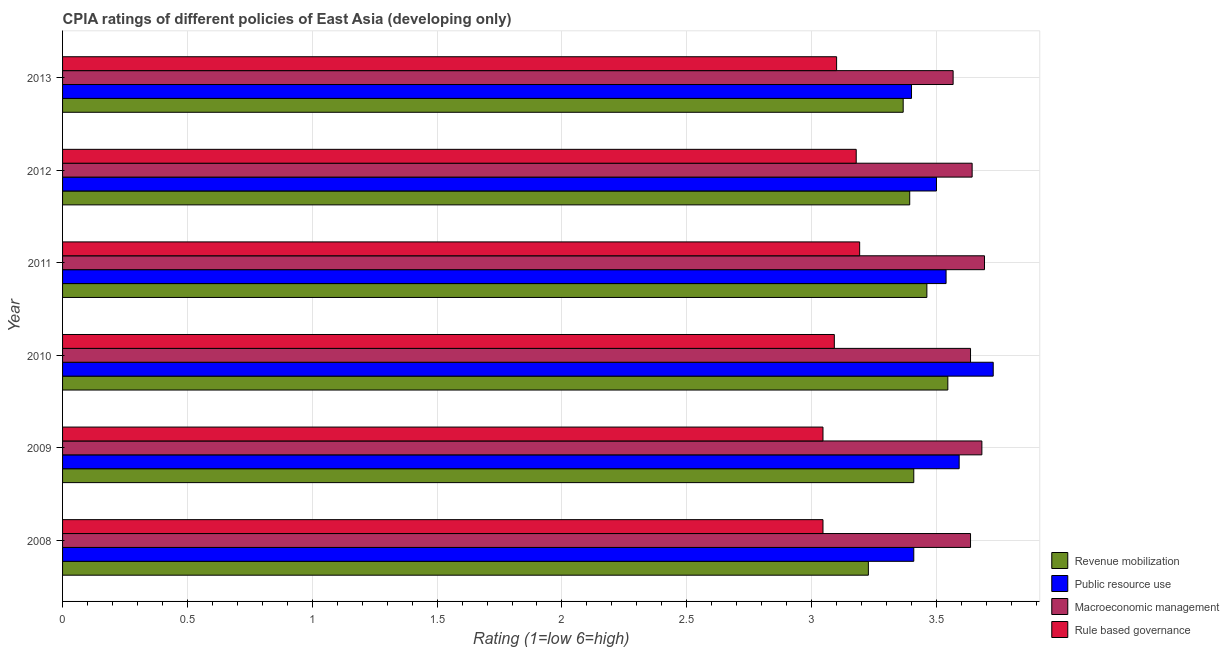How many different coloured bars are there?
Make the answer very short. 4. How many groups of bars are there?
Your answer should be compact. 6. Are the number of bars per tick equal to the number of legend labels?
Offer a terse response. Yes. Are the number of bars on each tick of the Y-axis equal?
Offer a terse response. Yes. How many bars are there on the 4th tick from the top?
Provide a succinct answer. 4. How many bars are there on the 4th tick from the bottom?
Your answer should be very brief. 4. What is the label of the 5th group of bars from the top?
Make the answer very short. 2009. In how many cases, is the number of bars for a given year not equal to the number of legend labels?
Your answer should be very brief. 0. What is the cpia rating of revenue mobilization in 2010?
Make the answer very short. 3.55. Across all years, what is the maximum cpia rating of revenue mobilization?
Your response must be concise. 3.55. Across all years, what is the minimum cpia rating of macroeconomic management?
Offer a terse response. 3.57. In which year was the cpia rating of revenue mobilization minimum?
Give a very brief answer. 2008. What is the total cpia rating of revenue mobilization in the graph?
Your response must be concise. 20.4. What is the difference between the cpia rating of revenue mobilization in 2008 and that in 2012?
Your answer should be very brief. -0.17. What is the difference between the cpia rating of public resource use in 2008 and the cpia rating of macroeconomic management in 2012?
Your response must be concise. -0.23. What is the average cpia rating of rule based governance per year?
Provide a short and direct response. 3.11. In how many years, is the cpia rating of macroeconomic management greater than 3.2 ?
Make the answer very short. 6. Is the difference between the cpia rating of macroeconomic management in 2008 and 2013 greater than the difference between the cpia rating of rule based governance in 2008 and 2013?
Your answer should be very brief. Yes. What is the difference between the highest and the second highest cpia rating of revenue mobilization?
Your answer should be very brief. 0.08. In how many years, is the cpia rating of rule based governance greater than the average cpia rating of rule based governance taken over all years?
Your answer should be very brief. 2. Is the sum of the cpia rating of rule based governance in 2010 and 2011 greater than the maximum cpia rating of revenue mobilization across all years?
Offer a terse response. Yes. Is it the case that in every year, the sum of the cpia rating of macroeconomic management and cpia rating of revenue mobilization is greater than the sum of cpia rating of rule based governance and cpia rating of public resource use?
Your answer should be very brief. Yes. What does the 4th bar from the top in 2008 represents?
Your answer should be very brief. Revenue mobilization. What does the 3rd bar from the bottom in 2010 represents?
Your response must be concise. Macroeconomic management. Is it the case that in every year, the sum of the cpia rating of revenue mobilization and cpia rating of public resource use is greater than the cpia rating of macroeconomic management?
Provide a short and direct response. Yes. How many bars are there?
Give a very brief answer. 24. Are all the bars in the graph horizontal?
Provide a short and direct response. Yes. How many years are there in the graph?
Your response must be concise. 6. Does the graph contain any zero values?
Make the answer very short. No. Does the graph contain grids?
Provide a short and direct response. Yes. Where does the legend appear in the graph?
Keep it short and to the point. Bottom right. How many legend labels are there?
Offer a very short reply. 4. What is the title of the graph?
Provide a succinct answer. CPIA ratings of different policies of East Asia (developing only). Does "Tertiary education" appear as one of the legend labels in the graph?
Make the answer very short. No. What is the label or title of the X-axis?
Ensure brevity in your answer.  Rating (1=low 6=high). What is the label or title of the Y-axis?
Keep it short and to the point. Year. What is the Rating (1=low 6=high) of Revenue mobilization in 2008?
Your response must be concise. 3.23. What is the Rating (1=low 6=high) of Public resource use in 2008?
Your answer should be very brief. 3.41. What is the Rating (1=low 6=high) of Macroeconomic management in 2008?
Your response must be concise. 3.64. What is the Rating (1=low 6=high) in Rule based governance in 2008?
Your response must be concise. 3.05. What is the Rating (1=low 6=high) in Revenue mobilization in 2009?
Give a very brief answer. 3.41. What is the Rating (1=low 6=high) in Public resource use in 2009?
Your answer should be very brief. 3.59. What is the Rating (1=low 6=high) in Macroeconomic management in 2009?
Your answer should be very brief. 3.68. What is the Rating (1=low 6=high) of Rule based governance in 2009?
Provide a succinct answer. 3.05. What is the Rating (1=low 6=high) of Revenue mobilization in 2010?
Your answer should be compact. 3.55. What is the Rating (1=low 6=high) of Public resource use in 2010?
Your response must be concise. 3.73. What is the Rating (1=low 6=high) of Macroeconomic management in 2010?
Make the answer very short. 3.64. What is the Rating (1=low 6=high) in Rule based governance in 2010?
Your answer should be very brief. 3.09. What is the Rating (1=low 6=high) in Revenue mobilization in 2011?
Give a very brief answer. 3.46. What is the Rating (1=low 6=high) of Public resource use in 2011?
Make the answer very short. 3.54. What is the Rating (1=low 6=high) in Macroeconomic management in 2011?
Your answer should be very brief. 3.69. What is the Rating (1=low 6=high) in Rule based governance in 2011?
Your answer should be compact. 3.19. What is the Rating (1=low 6=high) of Revenue mobilization in 2012?
Ensure brevity in your answer.  3.39. What is the Rating (1=low 6=high) of Macroeconomic management in 2012?
Ensure brevity in your answer.  3.64. What is the Rating (1=low 6=high) in Rule based governance in 2012?
Your answer should be very brief. 3.18. What is the Rating (1=low 6=high) of Revenue mobilization in 2013?
Offer a terse response. 3.37. What is the Rating (1=low 6=high) of Public resource use in 2013?
Give a very brief answer. 3.4. What is the Rating (1=low 6=high) of Macroeconomic management in 2013?
Offer a terse response. 3.57. Across all years, what is the maximum Rating (1=low 6=high) in Revenue mobilization?
Your answer should be compact. 3.55. Across all years, what is the maximum Rating (1=low 6=high) of Public resource use?
Give a very brief answer. 3.73. Across all years, what is the maximum Rating (1=low 6=high) in Macroeconomic management?
Your answer should be very brief. 3.69. Across all years, what is the maximum Rating (1=low 6=high) in Rule based governance?
Provide a short and direct response. 3.19. Across all years, what is the minimum Rating (1=low 6=high) of Revenue mobilization?
Your answer should be compact. 3.23. Across all years, what is the minimum Rating (1=low 6=high) in Macroeconomic management?
Make the answer very short. 3.57. Across all years, what is the minimum Rating (1=low 6=high) of Rule based governance?
Ensure brevity in your answer.  3.05. What is the total Rating (1=low 6=high) of Revenue mobilization in the graph?
Provide a short and direct response. 20.4. What is the total Rating (1=low 6=high) in Public resource use in the graph?
Make the answer very short. 21.17. What is the total Rating (1=low 6=high) in Macroeconomic management in the graph?
Give a very brief answer. 21.86. What is the total Rating (1=low 6=high) of Rule based governance in the graph?
Provide a short and direct response. 18.65. What is the difference between the Rating (1=low 6=high) in Revenue mobilization in 2008 and that in 2009?
Offer a very short reply. -0.18. What is the difference between the Rating (1=low 6=high) of Public resource use in 2008 and that in 2009?
Ensure brevity in your answer.  -0.18. What is the difference between the Rating (1=low 6=high) in Macroeconomic management in 2008 and that in 2009?
Provide a succinct answer. -0.05. What is the difference between the Rating (1=low 6=high) in Rule based governance in 2008 and that in 2009?
Your answer should be very brief. 0. What is the difference between the Rating (1=low 6=high) of Revenue mobilization in 2008 and that in 2010?
Keep it short and to the point. -0.32. What is the difference between the Rating (1=low 6=high) of Public resource use in 2008 and that in 2010?
Your answer should be very brief. -0.32. What is the difference between the Rating (1=low 6=high) in Macroeconomic management in 2008 and that in 2010?
Your answer should be compact. 0. What is the difference between the Rating (1=low 6=high) in Rule based governance in 2008 and that in 2010?
Your answer should be very brief. -0.05. What is the difference between the Rating (1=low 6=high) of Revenue mobilization in 2008 and that in 2011?
Provide a succinct answer. -0.23. What is the difference between the Rating (1=low 6=high) of Public resource use in 2008 and that in 2011?
Ensure brevity in your answer.  -0.13. What is the difference between the Rating (1=low 6=high) of Macroeconomic management in 2008 and that in 2011?
Your answer should be compact. -0.06. What is the difference between the Rating (1=low 6=high) of Rule based governance in 2008 and that in 2011?
Keep it short and to the point. -0.15. What is the difference between the Rating (1=low 6=high) of Revenue mobilization in 2008 and that in 2012?
Your answer should be very brief. -0.17. What is the difference between the Rating (1=low 6=high) in Public resource use in 2008 and that in 2012?
Offer a very short reply. -0.09. What is the difference between the Rating (1=low 6=high) of Macroeconomic management in 2008 and that in 2012?
Offer a very short reply. -0.01. What is the difference between the Rating (1=low 6=high) in Rule based governance in 2008 and that in 2012?
Ensure brevity in your answer.  -0.13. What is the difference between the Rating (1=low 6=high) of Revenue mobilization in 2008 and that in 2013?
Offer a very short reply. -0.14. What is the difference between the Rating (1=low 6=high) of Public resource use in 2008 and that in 2013?
Provide a short and direct response. 0.01. What is the difference between the Rating (1=low 6=high) of Macroeconomic management in 2008 and that in 2013?
Provide a short and direct response. 0.07. What is the difference between the Rating (1=low 6=high) in Rule based governance in 2008 and that in 2013?
Your response must be concise. -0.05. What is the difference between the Rating (1=low 6=high) of Revenue mobilization in 2009 and that in 2010?
Provide a succinct answer. -0.14. What is the difference between the Rating (1=low 6=high) of Public resource use in 2009 and that in 2010?
Offer a very short reply. -0.14. What is the difference between the Rating (1=low 6=high) in Macroeconomic management in 2009 and that in 2010?
Ensure brevity in your answer.  0.05. What is the difference between the Rating (1=low 6=high) of Rule based governance in 2009 and that in 2010?
Ensure brevity in your answer.  -0.05. What is the difference between the Rating (1=low 6=high) of Revenue mobilization in 2009 and that in 2011?
Offer a terse response. -0.05. What is the difference between the Rating (1=low 6=high) of Public resource use in 2009 and that in 2011?
Give a very brief answer. 0.05. What is the difference between the Rating (1=low 6=high) in Macroeconomic management in 2009 and that in 2011?
Your answer should be very brief. -0.01. What is the difference between the Rating (1=low 6=high) of Rule based governance in 2009 and that in 2011?
Offer a very short reply. -0.15. What is the difference between the Rating (1=low 6=high) in Revenue mobilization in 2009 and that in 2012?
Ensure brevity in your answer.  0.02. What is the difference between the Rating (1=low 6=high) in Public resource use in 2009 and that in 2012?
Offer a very short reply. 0.09. What is the difference between the Rating (1=low 6=high) of Macroeconomic management in 2009 and that in 2012?
Provide a short and direct response. 0.04. What is the difference between the Rating (1=low 6=high) in Rule based governance in 2009 and that in 2012?
Offer a terse response. -0.13. What is the difference between the Rating (1=low 6=high) of Revenue mobilization in 2009 and that in 2013?
Your answer should be compact. 0.04. What is the difference between the Rating (1=low 6=high) in Public resource use in 2009 and that in 2013?
Your response must be concise. 0.19. What is the difference between the Rating (1=low 6=high) in Macroeconomic management in 2009 and that in 2013?
Give a very brief answer. 0.12. What is the difference between the Rating (1=low 6=high) in Rule based governance in 2009 and that in 2013?
Give a very brief answer. -0.05. What is the difference between the Rating (1=low 6=high) of Revenue mobilization in 2010 and that in 2011?
Offer a very short reply. 0.08. What is the difference between the Rating (1=low 6=high) in Public resource use in 2010 and that in 2011?
Ensure brevity in your answer.  0.19. What is the difference between the Rating (1=low 6=high) of Macroeconomic management in 2010 and that in 2011?
Your answer should be compact. -0.06. What is the difference between the Rating (1=low 6=high) in Rule based governance in 2010 and that in 2011?
Offer a very short reply. -0.1. What is the difference between the Rating (1=low 6=high) in Revenue mobilization in 2010 and that in 2012?
Provide a succinct answer. 0.15. What is the difference between the Rating (1=low 6=high) of Public resource use in 2010 and that in 2012?
Offer a very short reply. 0.23. What is the difference between the Rating (1=low 6=high) in Macroeconomic management in 2010 and that in 2012?
Give a very brief answer. -0.01. What is the difference between the Rating (1=low 6=high) in Rule based governance in 2010 and that in 2012?
Offer a terse response. -0.09. What is the difference between the Rating (1=low 6=high) of Revenue mobilization in 2010 and that in 2013?
Offer a terse response. 0.18. What is the difference between the Rating (1=low 6=high) in Public resource use in 2010 and that in 2013?
Offer a terse response. 0.33. What is the difference between the Rating (1=low 6=high) in Macroeconomic management in 2010 and that in 2013?
Keep it short and to the point. 0.07. What is the difference between the Rating (1=low 6=high) in Rule based governance in 2010 and that in 2013?
Keep it short and to the point. -0.01. What is the difference between the Rating (1=low 6=high) of Revenue mobilization in 2011 and that in 2012?
Keep it short and to the point. 0.07. What is the difference between the Rating (1=low 6=high) of Public resource use in 2011 and that in 2012?
Make the answer very short. 0.04. What is the difference between the Rating (1=low 6=high) in Macroeconomic management in 2011 and that in 2012?
Make the answer very short. 0.05. What is the difference between the Rating (1=low 6=high) of Rule based governance in 2011 and that in 2012?
Your response must be concise. 0.01. What is the difference between the Rating (1=low 6=high) of Revenue mobilization in 2011 and that in 2013?
Keep it short and to the point. 0.09. What is the difference between the Rating (1=low 6=high) in Public resource use in 2011 and that in 2013?
Make the answer very short. 0.14. What is the difference between the Rating (1=low 6=high) in Macroeconomic management in 2011 and that in 2013?
Your answer should be very brief. 0.13. What is the difference between the Rating (1=low 6=high) in Rule based governance in 2011 and that in 2013?
Your response must be concise. 0.09. What is the difference between the Rating (1=low 6=high) in Revenue mobilization in 2012 and that in 2013?
Make the answer very short. 0.03. What is the difference between the Rating (1=low 6=high) of Public resource use in 2012 and that in 2013?
Your answer should be compact. 0.1. What is the difference between the Rating (1=low 6=high) in Macroeconomic management in 2012 and that in 2013?
Ensure brevity in your answer.  0.08. What is the difference between the Rating (1=low 6=high) in Rule based governance in 2012 and that in 2013?
Offer a terse response. 0.08. What is the difference between the Rating (1=low 6=high) of Revenue mobilization in 2008 and the Rating (1=low 6=high) of Public resource use in 2009?
Provide a succinct answer. -0.36. What is the difference between the Rating (1=low 6=high) in Revenue mobilization in 2008 and the Rating (1=low 6=high) in Macroeconomic management in 2009?
Make the answer very short. -0.45. What is the difference between the Rating (1=low 6=high) of Revenue mobilization in 2008 and the Rating (1=low 6=high) of Rule based governance in 2009?
Provide a short and direct response. 0.18. What is the difference between the Rating (1=low 6=high) of Public resource use in 2008 and the Rating (1=low 6=high) of Macroeconomic management in 2009?
Your answer should be very brief. -0.27. What is the difference between the Rating (1=low 6=high) of Public resource use in 2008 and the Rating (1=low 6=high) of Rule based governance in 2009?
Your response must be concise. 0.36. What is the difference between the Rating (1=low 6=high) in Macroeconomic management in 2008 and the Rating (1=low 6=high) in Rule based governance in 2009?
Give a very brief answer. 0.59. What is the difference between the Rating (1=low 6=high) in Revenue mobilization in 2008 and the Rating (1=low 6=high) in Macroeconomic management in 2010?
Provide a short and direct response. -0.41. What is the difference between the Rating (1=low 6=high) of Revenue mobilization in 2008 and the Rating (1=low 6=high) of Rule based governance in 2010?
Your answer should be very brief. 0.14. What is the difference between the Rating (1=low 6=high) in Public resource use in 2008 and the Rating (1=low 6=high) in Macroeconomic management in 2010?
Offer a terse response. -0.23. What is the difference between the Rating (1=low 6=high) of Public resource use in 2008 and the Rating (1=low 6=high) of Rule based governance in 2010?
Offer a terse response. 0.32. What is the difference between the Rating (1=low 6=high) in Macroeconomic management in 2008 and the Rating (1=low 6=high) in Rule based governance in 2010?
Ensure brevity in your answer.  0.55. What is the difference between the Rating (1=low 6=high) of Revenue mobilization in 2008 and the Rating (1=low 6=high) of Public resource use in 2011?
Provide a short and direct response. -0.31. What is the difference between the Rating (1=low 6=high) in Revenue mobilization in 2008 and the Rating (1=low 6=high) in Macroeconomic management in 2011?
Ensure brevity in your answer.  -0.47. What is the difference between the Rating (1=low 6=high) in Revenue mobilization in 2008 and the Rating (1=low 6=high) in Rule based governance in 2011?
Keep it short and to the point. 0.04. What is the difference between the Rating (1=low 6=high) in Public resource use in 2008 and the Rating (1=low 6=high) in Macroeconomic management in 2011?
Your response must be concise. -0.28. What is the difference between the Rating (1=low 6=high) of Public resource use in 2008 and the Rating (1=low 6=high) of Rule based governance in 2011?
Ensure brevity in your answer.  0.22. What is the difference between the Rating (1=low 6=high) in Macroeconomic management in 2008 and the Rating (1=low 6=high) in Rule based governance in 2011?
Make the answer very short. 0.44. What is the difference between the Rating (1=low 6=high) of Revenue mobilization in 2008 and the Rating (1=low 6=high) of Public resource use in 2012?
Ensure brevity in your answer.  -0.27. What is the difference between the Rating (1=low 6=high) of Revenue mobilization in 2008 and the Rating (1=low 6=high) of Macroeconomic management in 2012?
Keep it short and to the point. -0.42. What is the difference between the Rating (1=low 6=high) in Revenue mobilization in 2008 and the Rating (1=low 6=high) in Rule based governance in 2012?
Keep it short and to the point. 0.05. What is the difference between the Rating (1=low 6=high) of Public resource use in 2008 and the Rating (1=low 6=high) of Macroeconomic management in 2012?
Make the answer very short. -0.23. What is the difference between the Rating (1=low 6=high) of Public resource use in 2008 and the Rating (1=low 6=high) of Rule based governance in 2012?
Make the answer very short. 0.23. What is the difference between the Rating (1=low 6=high) of Macroeconomic management in 2008 and the Rating (1=low 6=high) of Rule based governance in 2012?
Give a very brief answer. 0.46. What is the difference between the Rating (1=low 6=high) of Revenue mobilization in 2008 and the Rating (1=low 6=high) of Public resource use in 2013?
Keep it short and to the point. -0.17. What is the difference between the Rating (1=low 6=high) of Revenue mobilization in 2008 and the Rating (1=low 6=high) of Macroeconomic management in 2013?
Provide a short and direct response. -0.34. What is the difference between the Rating (1=low 6=high) of Revenue mobilization in 2008 and the Rating (1=low 6=high) of Rule based governance in 2013?
Provide a short and direct response. 0.13. What is the difference between the Rating (1=low 6=high) of Public resource use in 2008 and the Rating (1=low 6=high) of Macroeconomic management in 2013?
Keep it short and to the point. -0.16. What is the difference between the Rating (1=low 6=high) in Public resource use in 2008 and the Rating (1=low 6=high) in Rule based governance in 2013?
Keep it short and to the point. 0.31. What is the difference between the Rating (1=low 6=high) of Macroeconomic management in 2008 and the Rating (1=low 6=high) of Rule based governance in 2013?
Provide a succinct answer. 0.54. What is the difference between the Rating (1=low 6=high) of Revenue mobilization in 2009 and the Rating (1=low 6=high) of Public resource use in 2010?
Your answer should be compact. -0.32. What is the difference between the Rating (1=low 6=high) in Revenue mobilization in 2009 and the Rating (1=low 6=high) in Macroeconomic management in 2010?
Offer a terse response. -0.23. What is the difference between the Rating (1=low 6=high) in Revenue mobilization in 2009 and the Rating (1=low 6=high) in Rule based governance in 2010?
Ensure brevity in your answer.  0.32. What is the difference between the Rating (1=low 6=high) of Public resource use in 2009 and the Rating (1=low 6=high) of Macroeconomic management in 2010?
Keep it short and to the point. -0.05. What is the difference between the Rating (1=low 6=high) of Macroeconomic management in 2009 and the Rating (1=low 6=high) of Rule based governance in 2010?
Provide a short and direct response. 0.59. What is the difference between the Rating (1=low 6=high) of Revenue mobilization in 2009 and the Rating (1=low 6=high) of Public resource use in 2011?
Provide a short and direct response. -0.13. What is the difference between the Rating (1=low 6=high) of Revenue mobilization in 2009 and the Rating (1=low 6=high) of Macroeconomic management in 2011?
Keep it short and to the point. -0.28. What is the difference between the Rating (1=low 6=high) in Revenue mobilization in 2009 and the Rating (1=low 6=high) in Rule based governance in 2011?
Your answer should be very brief. 0.22. What is the difference between the Rating (1=low 6=high) of Public resource use in 2009 and the Rating (1=low 6=high) of Macroeconomic management in 2011?
Offer a terse response. -0.1. What is the difference between the Rating (1=low 6=high) of Public resource use in 2009 and the Rating (1=low 6=high) of Rule based governance in 2011?
Your response must be concise. 0.4. What is the difference between the Rating (1=low 6=high) of Macroeconomic management in 2009 and the Rating (1=low 6=high) of Rule based governance in 2011?
Provide a succinct answer. 0.49. What is the difference between the Rating (1=low 6=high) in Revenue mobilization in 2009 and the Rating (1=low 6=high) in Public resource use in 2012?
Make the answer very short. -0.09. What is the difference between the Rating (1=low 6=high) of Revenue mobilization in 2009 and the Rating (1=low 6=high) of Macroeconomic management in 2012?
Make the answer very short. -0.23. What is the difference between the Rating (1=low 6=high) of Revenue mobilization in 2009 and the Rating (1=low 6=high) of Rule based governance in 2012?
Make the answer very short. 0.23. What is the difference between the Rating (1=low 6=high) in Public resource use in 2009 and the Rating (1=low 6=high) in Macroeconomic management in 2012?
Provide a short and direct response. -0.05. What is the difference between the Rating (1=low 6=high) in Public resource use in 2009 and the Rating (1=low 6=high) in Rule based governance in 2012?
Provide a short and direct response. 0.41. What is the difference between the Rating (1=low 6=high) in Macroeconomic management in 2009 and the Rating (1=low 6=high) in Rule based governance in 2012?
Ensure brevity in your answer.  0.5. What is the difference between the Rating (1=low 6=high) in Revenue mobilization in 2009 and the Rating (1=low 6=high) in Public resource use in 2013?
Ensure brevity in your answer.  0.01. What is the difference between the Rating (1=low 6=high) in Revenue mobilization in 2009 and the Rating (1=low 6=high) in Macroeconomic management in 2013?
Your answer should be very brief. -0.16. What is the difference between the Rating (1=low 6=high) in Revenue mobilization in 2009 and the Rating (1=low 6=high) in Rule based governance in 2013?
Ensure brevity in your answer.  0.31. What is the difference between the Rating (1=low 6=high) of Public resource use in 2009 and the Rating (1=low 6=high) of Macroeconomic management in 2013?
Offer a very short reply. 0.02. What is the difference between the Rating (1=low 6=high) of Public resource use in 2009 and the Rating (1=low 6=high) of Rule based governance in 2013?
Offer a very short reply. 0.49. What is the difference between the Rating (1=low 6=high) of Macroeconomic management in 2009 and the Rating (1=low 6=high) of Rule based governance in 2013?
Offer a very short reply. 0.58. What is the difference between the Rating (1=low 6=high) of Revenue mobilization in 2010 and the Rating (1=low 6=high) of Public resource use in 2011?
Ensure brevity in your answer.  0.01. What is the difference between the Rating (1=low 6=high) of Revenue mobilization in 2010 and the Rating (1=low 6=high) of Macroeconomic management in 2011?
Ensure brevity in your answer.  -0.15. What is the difference between the Rating (1=low 6=high) of Revenue mobilization in 2010 and the Rating (1=low 6=high) of Rule based governance in 2011?
Make the answer very short. 0.35. What is the difference between the Rating (1=low 6=high) in Public resource use in 2010 and the Rating (1=low 6=high) in Macroeconomic management in 2011?
Your response must be concise. 0.04. What is the difference between the Rating (1=low 6=high) in Public resource use in 2010 and the Rating (1=low 6=high) in Rule based governance in 2011?
Your response must be concise. 0.54. What is the difference between the Rating (1=low 6=high) of Macroeconomic management in 2010 and the Rating (1=low 6=high) of Rule based governance in 2011?
Keep it short and to the point. 0.44. What is the difference between the Rating (1=low 6=high) in Revenue mobilization in 2010 and the Rating (1=low 6=high) in Public resource use in 2012?
Offer a very short reply. 0.05. What is the difference between the Rating (1=low 6=high) of Revenue mobilization in 2010 and the Rating (1=low 6=high) of Macroeconomic management in 2012?
Your answer should be very brief. -0.1. What is the difference between the Rating (1=low 6=high) of Revenue mobilization in 2010 and the Rating (1=low 6=high) of Rule based governance in 2012?
Your answer should be compact. 0.37. What is the difference between the Rating (1=low 6=high) of Public resource use in 2010 and the Rating (1=low 6=high) of Macroeconomic management in 2012?
Make the answer very short. 0.08. What is the difference between the Rating (1=low 6=high) of Public resource use in 2010 and the Rating (1=low 6=high) of Rule based governance in 2012?
Your answer should be compact. 0.55. What is the difference between the Rating (1=low 6=high) of Macroeconomic management in 2010 and the Rating (1=low 6=high) of Rule based governance in 2012?
Provide a succinct answer. 0.46. What is the difference between the Rating (1=low 6=high) of Revenue mobilization in 2010 and the Rating (1=low 6=high) of Public resource use in 2013?
Offer a very short reply. 0.15. What is the difference between the Rating (1=low 6=high) in Revenue mobilization in 2010 and the Rating (1=low 6=high) in Macroeconomic management in 2013?
Provide a short and direct response. -0.02. What is the difference between the Rating (1=low 6=high) in Revenue mobilization in 2010 and the Rating (1=low 6=high) in Rule based governance in 2013?
Make the answer very short. 0.45. What is the difference between the Rating (1=low 6=high) in Public resource use in 2010 and the Rating (1=low 6=high) in Macroeconomic management in 2013?
Your response must be concise. 0.16. What is the difference between the Rating (1=low 6=high) of Public resource use in 2010 and the Rating (1=low 6=high) of Rule based governance in 2013?
Your answer should be very brief. 0.63. What is the difference between the Rating (1=low 6=high) in Macroeconomic management in 2010 and the Rating (1=low 6=high) in Rule based governance in 2013?
Provide a succinct answer. 0.54. What is the difference between the Rating (1=low 6=high) in Revenue mobilization in 2011 and the Rating (1=low 6=high) in Public resource use in 2012?
Offer a terse response. -0.04. What is the difference between the Rating (1=low 6=high) in Revenue mobilization in 2011 and the Rating (1=low 6=high) in Macroeconomic management in 2012?
Offer a terse response. -0.18. What is the difference between the Rating (1=low 6=high) of Revenue mobilization in 2011 and the Rating (1=low 6=high) of Rule based governance in 2012?
Your answer should be very brief. 0.28. What is the difference between the Rating (1=low 6=high) in Public resource use in 2011 and the Rating (1=low 6=high) in Macroeconomic management in 2012?
Ensure brevity in your answer.  -0.1. What is the difference between the Rating (1=low 6=high) of Public resource use in 2011 and the Rating (1=low 6=high) of Rule based governance in 2012?
Your answer should be compact. 0.36. What is the difference between the Rating (1=low 6=high) in Macroeconomic management in 2011 and the Rating (1=low 6=high) in Rule based governance in 2012?
Provide a succinct answer. 0.51. What is the difference between the Rating (1=low 6=high) of Revenue mobilization in 2011 and the Rating (1=low 6=high) of Public resource use in 2013?
Make the answer very short. 0.06. What is the difference between the Rating (1=low 6=high) in Revenue mobilization in 2011 and the Rating (1=low 6=high) in Macroeconomic management in 2013?
Your answer should be very brief. -0.11. What is the difference between the Rating (1=low 6=high) of Revenue mobilization in 2011 and the Rating (1=low 6=high) of Rule based governance in 2013?
Your answer should be compact. 0.36. What is the difference between the Rating (1=low 6=high) in Public resource use in 2011 and the Rating (1=low 6=high) in Macroeconomic management in 2013?
Keep it short and to the point. -0.03. What is the difference between the Rating (1=low 6=high) of Public resource use in 2011 and the Rating (1=low 6=high) of Rule based governance in 2013?
Offer a very short reply. 0.44. What is the difference between the Rating (1=low 6=high) of Macroeconomic management in 2011 and the Rating (1=low 6=high) of Rule based governance in 2013?
Your answer should be very brief. 0.59. What is the difference between the Rating (1=low 6=high) of Revenue mobilization in 2012 and the Rating (1=low 6=high) of Public resource use in 2013?
Make the answer very short. -0.01. What is the difference between the Rating (1=low 6=high) of Revenue mobilization in 2012 and the Rating (1=low 6=high) of Macroeconomic management in 2013?
Your answer should be very brief. -0.17. What is the difference between the Rating (1=low 6=high) in Revenue mobilization in 2012 and the Rating (1=low 6=high) in Rule based governance in 2013?
Your answer should be very brief. 0.29. What is the difference between the Rating (1=low 6=high) of Public resource use in 2012 and the Rating (1=low 6=high) of Macroeconomic management in 2013?
Your answer should be compact. -0.07. What is the difference between the Rating (1=low 6=high) of Public resource use in 2012 and the Rating (1=low 6=high) of Rule based governance in 2013?
Your response must be concise. 0.4. What is the difference between the Rating (1=low 6=high) in Macroeconomic management in 2012 and the Rating (1=low 6=high) in Rule based governance in 2013?
Your answer should be very brief. 0.54. What is the average Rating (1=low 6=high) in Revenue mobilization per year?
Your answer should be compact. 3.4. What is the average Rating (1=low 6=high) of Public resource use per year?
Keep it short and to the point. 3.53. What is the average Rating (1=low 6=high) of Macroeconomic management per year?
Make the answer very short. 3.64. What is the average Rating (1=low 6=high) in Rule based governance per year?
Make the answer very short. 3.11. In the year 2008, what is the difference between the Rating (1=low 6=high) of Revenue mobilization and Rating (1=low 6=high) of Public resource use?
Provide a short and direct response. -0.18. In the year 2008, what is the difference between the Rating (1=low 6=high) of Revenue mobilization and Rating (1=low 6=high) of Macroeconomic management?
Keep it short and to the point. -0.41. In the year 2008, what is the difference between the Rating (1=low 6=high) in Revenue mobilization and Rating (1=low 6=high) in Rule based governance?
Provide a succinct answer. 0.18. In the year 2008, what is the difference between the Rating (1=low 6=high) of Public resource use and Rating (1=low 6=high) of Macroeconomic management?
Keep it short and to the point. -0.23. In the year 2008, what is the difference between the Rating (1=low 6=high) in Public resource use and Rating (1=low 6=high) in Rule based governance?
Offer a terse response. 0.36. In the year 2008, what is the difference between the Rating (1=low 6=high) in Macroeconomic management and Rating (1=low 6=high) in Rule based governance?
Give a very brief answer. 0.59. In the year 2009, what is the difference between the Rating (1=low 6=high) in Revenue mobilization and Rating (1=low 6=high) in Public resource use?
Provide a short and direct response. -0.18. In the year 2009, what is the difference between the Rating (1=low 6=high) in Revenue mobilization and Rating (1=low 6=high) in Macroeconomic management?
Offer a terse response. -0.27. In the year 2009, what is the difference between the Rating (1=low 6=high) in Revenue mobilization and Rating (1=low 6=high) in Rule based governance?
Offer a terse response. 0.36. In the year 2009, what is the difference between the Rating (1=low 6=high) in Public resource use and Rating (1=low 6=high) in Macroeconomic management?
Give a very brief answer. -0.09. In the year 2009, what is the difference between the Rating (1=low 6=high) in Public resource use and Rating (1=low 6=high) in Rule based governance?
Offer a terse response. 0.55. In the year 2009, what is the difference between the Rating (1=low 6=high) of Macroeconomic management and Rating (1=low 6=high) of Rule based governance?
Your answer should be very brief. 0.64. In the year 2010, what is the difference between the Rating (1=low 6=high) in Revenue mobilization and Rating (1=low 6=high) in Public resource use?
Provide a succinct answer. -0.18. In the year 2010, what is the difference between the Rating (1=low 6=high) in Revenue mobilization and Rating (1=low 6=high) in Macroeconomic management?
Offer a very short reply. -0.09. In the year 2010, what is the difference between the Rating (1=low 6=high) of Revenue mobilization and Rating (1=low 6=high) of Rule based governance?
Your response must be concise. 0.45. In the year 2010, what is the difference between the Rating (1=low 6=high) of Public resource use and Rating (1=low 6=high) of Macroeconomic management?
Your answer should be compact. 0.09. In the year 2010, what is the difference between the Rating (1=low 6=high) in Public resource use and Rating (1=low 6=high) in Rule based governance?
Your answer should be compact. 0.64. In the year 2010, what is the difference between the Rating (1=low 6=high) of Macroeconomic management and Rating (1=low 6=high) of Rule based governance?
Ensure brevity in your answer.  0.55. In the year 2011, what is the difference between the Rating (1=low 6=high) of Revenue mobilization and Rating (1=low 6=high) of Public resource use?
Keep it short and to the point. -0.08. In the year 2011, what is the difference between the Rating (1=low 6=high) of Revenue mobilization and Rating (1=low 6=high) of Macroeconomic management?
Make the answer very short. -0.23. In the year 2011, what is the difference between the Rating (1=low 6=high) in Revenue mobilization and Rating (1=low 6=high) in Rule based governance?
Provide a short and direct response. 0.27. In the year 2011, what is the difference between the Rating (1=low 6=high) of Public resource use and Rating (1=low 6=high) of Macroeconomic management?
Offer a terse response. -0.15. In the year 2011, what is the difference between the Rating (1=low 6=high) of Public resource use and Rating (1=low 6=high) of Rule based governance?
Keep it short and to the point. 0.35. In the year 2012, what is the difference between the Rating (1=low 6=high) in Revenue mobilization and Rating (1=low 6=high) in Public resource use?
Provide a succinct answer. -0.11. In the year 2012, what is the difference between the Rating (1=low 6=high) in Revenue mobilization and Rating (1=low 6=high) in Rule based governance?
Offer a very short reply. 0.21. In the year 2012, what is the difference between the Rating (1=low 6=high) of Public resource use and Rating (1=low 6=high) of Macroeconomic management?
Give a very brief answer. -0.14. In the year 2012, what is the difference between the Rating (1=low 6=high) of Public resource use and Rating (1=low 6=high) of Rule based governance?
Offer a very short reply. 0.32. In the year 2012, what is the difference between the Rating (1=low 6=high) in Macroeconomic management and Rating (1=low 6=high) in Rule based governance?
Give a very brief answer. 0.46. In the year 2013, what is the difference between the Rating (1=low 6=high) of Revenue mobilization and Rating (1=low 6=high) of Public resource use?
Offer a terse response. -0.03. In the year 2013, what is the difference between the Rating (1=low 6=high) in Revenue mobilization and Rating (1=low 6=high) in Macroeconomic management?
Ensure brevity in your answer.  -0.2. In the year 2013, what is the difference between the Rating (1=low 6=high) in Revenue mobilization and Rating (1=low 6=high) in Rule based governance?
Provide a succinct answer. 0.27. In the year 2013, what is the difference between the Rating (1=low 6=high) of Public resource use and Rating (1=low 6=high) of Macroeconomic management?
Make the answer very short. -0.17. In the year 2013, what is the difference between the Rating (1=low 6=high) in Public resource use and Rating (1=low 6=high) in Rule based governance?
Provide a succinct answer. 0.3. In the year 2013, what is the difference between the Rating (1=low 6=high) of Macroeconomic management and Rating (1=low 6=high) of Rule based governance?
Provide a succinct answer. 0.47. What is the ratio of the Rating (1=low 6=high) of Revenue mobilization in 2008 to that in 2009?
Your answer should be compact. 0.95. What is the ratio of the Rating (1=low 6=high) of Public resource use in 2008 to that in 2009?
Your answer should be compact. 0.95. What is the ratio of the Rating (1=low 6=high) of Revenue mobilization in 2008 to that in 2010?
Make the answer very short. 0.91. What is the ratio of the Rating (1=low 6=high) in Public resource use in 2008 to that in 2010?
Offer a very short reply. 0.91. What is the ratio of the Rating (1=low 6=high) of Rule based governance in 2008 to that in 2010?
Keep it short and to the point. 0.99. What is the ratio of the Rating (1=low 6=high) in Revenue mobilization in 2008 to that in 2011?
Your answer should be very brief. 0.93. What is the ratio of the Rating (1=low 6=high) of Public resource use in 2008 to that in 2011?
Give a very brief answer. 0.96. What is the ratio of the Rating (1=low 6=high) of Macroeconomic management in 2008 to that in 2011?
Provide a succinct answer. 0.98. What is the ratio of the Rating (1=low 6=high) of Rule based governance in 2008 to that in 2011?
Your answer should be compact. 0.95. What is the ratio of the Rating (1=low 6=high) of Revenue mobilization in 2008 to that in 2012?
Give a very brief answer. 0.95. What is the ratio of the Rating (1=low 6=high) of Rule based governance in 2008 to that in 2012?
Offer a very short reply. 0.96. What is the ratio of the Rating (1=low 6=high) of Revenue mobilization in 2008 to that in 2013?
Make the answer very short. 0.96. What is the ratio of the Rating (1=low 6=high) of Macroeconomic management in 2008 to that in 2013?
Offer a very short reply. 1.02. What is the ratio of the Rating (1=low 6=high) in Rule based governance in 2008 to that in 2013?
Give a very brief answer. 0.98. What is the ratio of the Rating (1=low 6=high) of Revenue mobilization in 2009 to that in 2010?
Offer a very short reply. 0.96. What is the ratio of the Rating (1=low 6=high) in Public resource use in 2009 to that in 2010?
Offer a very short reply. 0.96. What is the ratio of the Rating (1=low 6=high) in Macroeconomic management in 2009 to that in 2010?
Your response must be concise. 1.01. What is the ratio of the Rating (1=low 6=high) of Rule based governance in 2009 to that in 2010?
Give a very brief answer. 0.99. What is the ratio of the Rating (1=low 6=high) in Revenue mobilization in 2009 to that in 2011?
Provide a short and direct response. 0.98. What is the ratio of the Rating (1=low 6=high) of Public resource use in 2009 to that in 2011?
Your response must be concise. 1.01. What is the ratio of the Rating (1=low 6=high) in Macroeconomic management in 2009 to that in 2011?
Your response must be concise. 1. What is the ratio of the Rating (1=low 6=high) in Rule based governance in 2009 to that in 2011?
Your answer should be very brief. 0.95. What is the ratio of the Rating (1=low 6=high) in Revenue mobilization in 2009 to that in 2012?
Provide a succinct answer. 1. What is the ratio of the Rating (1=low 6=high) of Macroeconomic management in 2009 to that in 2012?
Your answer should be very brief. 1.01. What is the ratio of the Rating (1=low 6=high) of Rule based governance in 2009 to that in 2012?
Make the answer very short. 0.96. What is the ratio of the Rating (1=low 6=high) of Revenue mobilization in 2009 to that in 2013?
Give a very brief answer. 1.01. What is the ratio of the Rating (1=low 6=high) of Public resource use in 2009 to that in 2013?
Offer a terse response. 1.06. What is the ratio of the Rating (1=low 6=high) in Macroeconomic management in 2009 to that in 2013?
Your response must be concise. 1.03. What is the ratio of the Rating (1=low 6=high) in Rule based governance in 2009 to that in 2013?
Your response must be concise. 0.98. What is the ratio of the Rating (1=low 6=high) of Revenue mobilization in 2010 to that in 2011?
Your answer should be very brief. 1.02. What is the ratio of the Rating (1=low 6=high) of Public resource use in 2010 to that in 2011?
Your answer should be compact. 1.05. What is the ratio of the Rating (1=low 6=high) in Rule based governance in 2010 to that in 2011?
Provide a succinct answer. 0.97. What is the ratio of the Rating (1=low 6=high) in Revenue mobilization in 2010 to that in 2012?
Provide a succinct answer. 1.04. What is the ratio of the Rating (1=low 6=high) in Public resource use in 2010 to that in 2012?
Your answer should be compact. 1.06. What is the ratio of the Rating (1=low 6=high) of Macroeconomic management in 2010 to that in 2012?
Provide a short and direct response. 1. What is the ratio of the Rating (1=low 6=high) in Rule based governance in 2010 to that in 2012?
Make the answer very short. 0.97. What is the ratio of the Rating (1=low 6=high) of Revenue mobilization in 2010 to that in 2013?
Keep it short and to the point. 1.05. What is the ratio of the Rating (1=low 6=high) of Public resource use in 2010 to that in 2013?
Provide a short and direct response. 1.1. What is the ratio of the Rating (1=low 6=high) in Macroeconomic management in 2010 to that in 2013?
Offer a very short reply. 1.02. What is the ratio of the Rating (1=low 6=high) of Revenue mobilization in 2011 to that in 2012?
Ensure brevity in your answer.  1.02. What is the ratio of the Rating (1=low 6=high) of Macroeconomic management in 2011 to that in 2012?
Keep it short and to the point. 1.01. What is the ratio of the Rating (1=low 6=high) of Revenue mobilization in 2011 to that in 2013?
Provide a succinct answer. 1.03. What is the ratio of the Rating (1=low 6=high) in Public resource use in 2011 to that in 2013?
Your answer should be very brief. 1.04. What is the ratio of the Rating (1=low 6=high) of Macroeconomic management in 2011 to that in 2013?
Provide a short and direct response. 1.04. What is the ratio of the Rating (1=low 6=high) in Rule based governance in 2011 to that in 2013?
Give a very brief answer. 1.03. What is the ratio of the Rating (1=low 6=high) of Revenue mobilization in 2012 to that in 2013?
Offer a very short reply. 1.01. What is the ratio of the Rating (1=low 6=high) of Public resource use in 2012 to that in 2013?
Provide a succinct answer. 1.03. What is the ratio of the Rating (1=low 6=high) of Macroeconomic management in 2012 to that in 2013?
Offer a very short reply. 1.02. What is the ratio of the Rating (1=low 6=high) in Rule based governance in 2012 to that in 2013?
Ensure brevity in your answer.  1.03. What is the difference between the highest and the second highest Rating (1=low 6=high) in Revenue mobilization?
Your answer should be compact. 0.08. What is the difference between the highest and the second highest Rating (1=low 6=high) in Public resource use?
Your response must be concise. 0.14. What is the difference between the highest and the second highest Rating (1=low 6=high) in Macroeconomic management?
Provide a succinct answer. 0.01. What is the difference between the highest and the second highest Rating (1=low 6=high) of Rule based governance?
Make the answer very short. 0.01. What is the difference between the highest and the lowest Rating (1=low 6=high) of Revenue mobilization?
Provide a succinct answer. 0.32. What is the difference between the highest and the lowest Rating (1=low 6=high) of Public resource use?
Your answer should be compact. 0.33. What is the difference between the highest and the lowest Rating (1=low 6=high) in Macroeconomic management?
Provide a succinct answer. 0.13. What is the difference between the highest and the lowest Rating (1=low 6=high) of Rule based governance?
Provide a succinct answer. 0.15. 